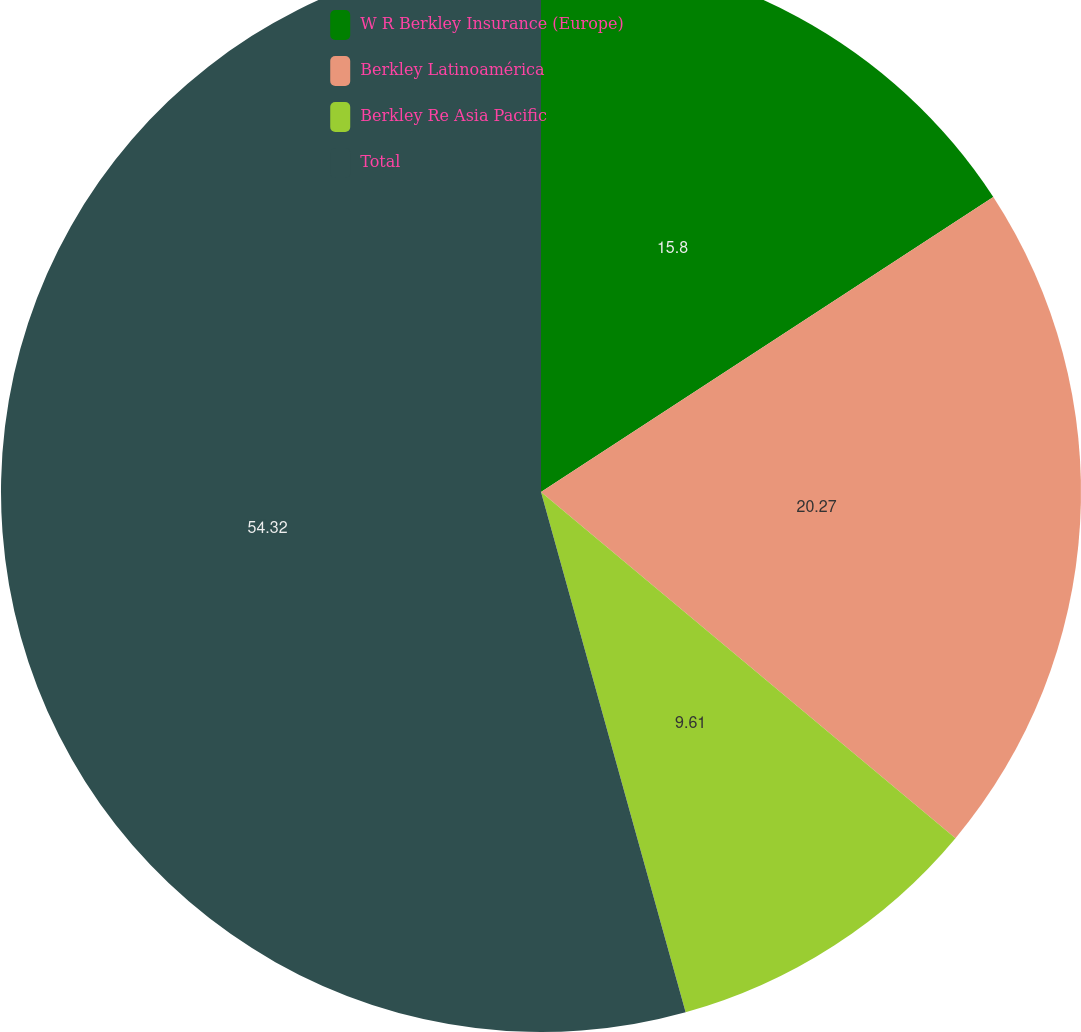Convert chart to OTSL. <chart><loc_0><loc_0><loc_500><loc_500><pie_chart><fcel>W R Berkley Insurance (Europe)<fcel>Berkley Latinoamérica<fcel>Berkley Re Asia Pacific<fcel>Total<nl><fcel>15.8%<fcel>20.27%<fcel>9.61%<fcel>54.31%<nl></chart> 